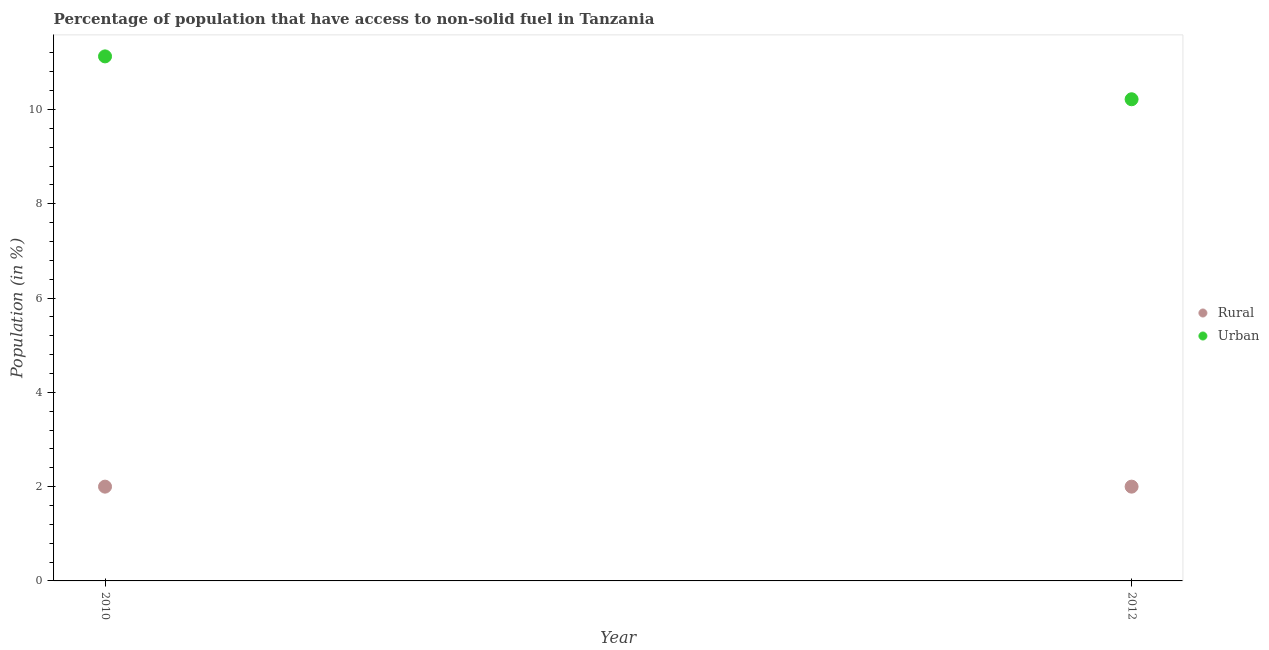How many different coloured dotlines are there?
Provide a succinct answer. 2. Is the number of dotlines equal to the number of legend labels?
Provide a short and direct response. Yes. What is the urban population in 2012?
Your response must be concise. 10.22. Across all years, what is the maximum rural population?
Provide a succinct answer. 2. Across all years, what is the minimum urban population?
Offer a terse response. 10.22. In which year was the rural population minimum?
Your answer should be compact. 2010. What is the total rural population in the graph?
Provide a short and direct response. 4. What is the difference between the rural population in 2010 and that in 2012?
Your answer should be compact. 0. What is the difference between the urban population in 2010 and the rural population in 2012?
Provide a short and direct response. 9.13. What is the average rural population per year?
Give a very brief answer. 2. In the year 2012, what is the difference between the rural population and urban population?
Keep it short and to the point. -8.22. What is the ratio of the urban population in 2010 to that in 2012?
Your response must be concise. 1.09. In how many years, is the rural population greater than the average rural population taken over all years?
Offer a terse response. 0. Does the urban population monotonically increase over the years?
Keep it short and to the point. No. How many years are there in the graph?
Keep it short and to the point. 2. What is the difference between two consecutive major ticks on the Y-axis?
Offer a very short reply. 2. Does the graph contain any zero values?
Your response must be concise. No. Where does the legend appear in the graph?
Your response must be concise. Center right. What is the title of the graph?
Give a very brief answer. Percentage of population that have access to non-solid fuel in Tanzania. What is the label or title of the Y-axis?
Keep it short and to the point. Population (in %). What is the Population (in %) of Rural in 2010?
Offer a terse response. 2. What is the Population (in %) of Urban in 2010?
Your answer should be very brief. 11.13. What is the Population (in %) of Rural in 2012?
Your answer should be very brief. 2. What is the Population (in %) of Urban in 2012?
Keep it short and to the point. 10.22. Across all years, what is the maximum Population (in %) in Rural?
Provide a succinct answer. 2. Across all years, what is the maximum Population (in %) of Urban?
Make the answer very short. 11.13. Across all years, what is the minimum Population (in %) in Rural?
Your answer should be very brief. 2. Across all years, what is the minimum Population (in %) of Urban?
Keep it short and to the point. 10.22. What is the total Population (in %) of Urban in the graph?
Keep it short and to the point. 21.34. What is the difference between the Population (in %) in Urban in 2010 and that in 2012?
Your answer should be very brief. 0.91. What is the difference between the Population (in %) in Rural in 2010 and the Population (in %) in Urban in 2012?
Your answer should be very brief. -8.22. What is the average Population (in %) in Urban per year?
Your response must be concise. 10.67. In the year 2010, what is the difference between the Population (in %) in Rural and Population (in %) in Urban?
Provide a short and direct response. -9.13. In the year 2012, what is the difference between the Population (in %) of Rural and Population (in %) of Urban?
Provide a short and direct response. -8.22. What is the ratio of the Population (in %) of Urban in 2010 to that in 2012?
Keep it short and to the point. 1.09. What is the difference between the highest and the second highest Population (in %) in Urban?
Your response must be concise. 0.91. What is the difference between the highest and the lowest Population (in %) in Rural?
Your answer should be very brief. 0. What is the difference between the highest and the lowest Population (in %) of Urban?
Your answer should be very brief. 0.91. 